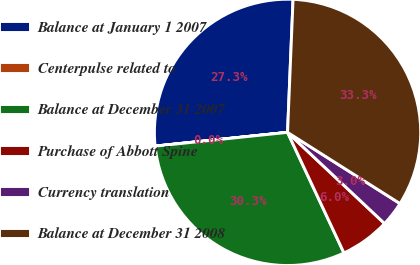Convert chart. <chart><loc_0><loc_0><loc_500><loc_500><pie_chart><fcel>Balance at January 1 2007<fcel>Centerpulse related to<fcel>Balance at December 31 2007<fcel>Purchase of Abbott Spine<fcel>Currency translation<fcel>Balance at December 31 2008<nl><fcel>27.3%<fcel>0.01%<fcel>30.31%<fcel>6.03%<fcel>3.02%<fcel>33.32%<nl></chart> 